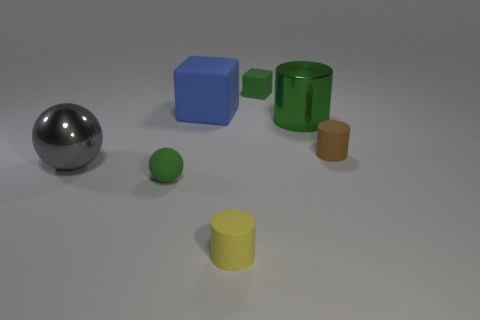Subtract all tiny cylinders. How many cylinders are left? 1 Subtract 1 spheres. How many spheres are left? 1 Subtract all yellow cylinders. How many cylinders are left? 2 Add 2 gray metal things. How many objects exist? 9 Subtract all gray balls. Subtract all purple matte things. How many objects are left? 6 Add 2 large objects. How many large objects are left? 5 Add 4 yellow rubber things. How many yellow rubber things exist? 5 Subtract 1 gray balls. How many objects are left? 6 Subtract all cylinders. How many objects are left? 4 Subtract all cyan blocks. Subtract all cyan spheres. How many blocks are left? 2 